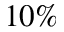<formula> <loc_0><loc_0><loc_500><loc_500>1 0 \%</formula> 